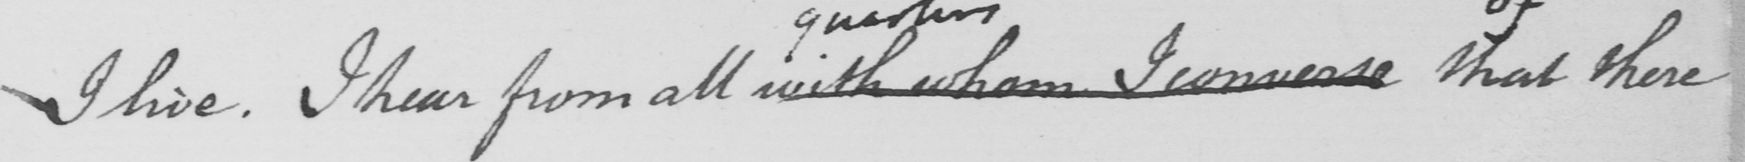Please transcribe the handwritten text in this image. I live . I hear from all with whom I converse that that there 